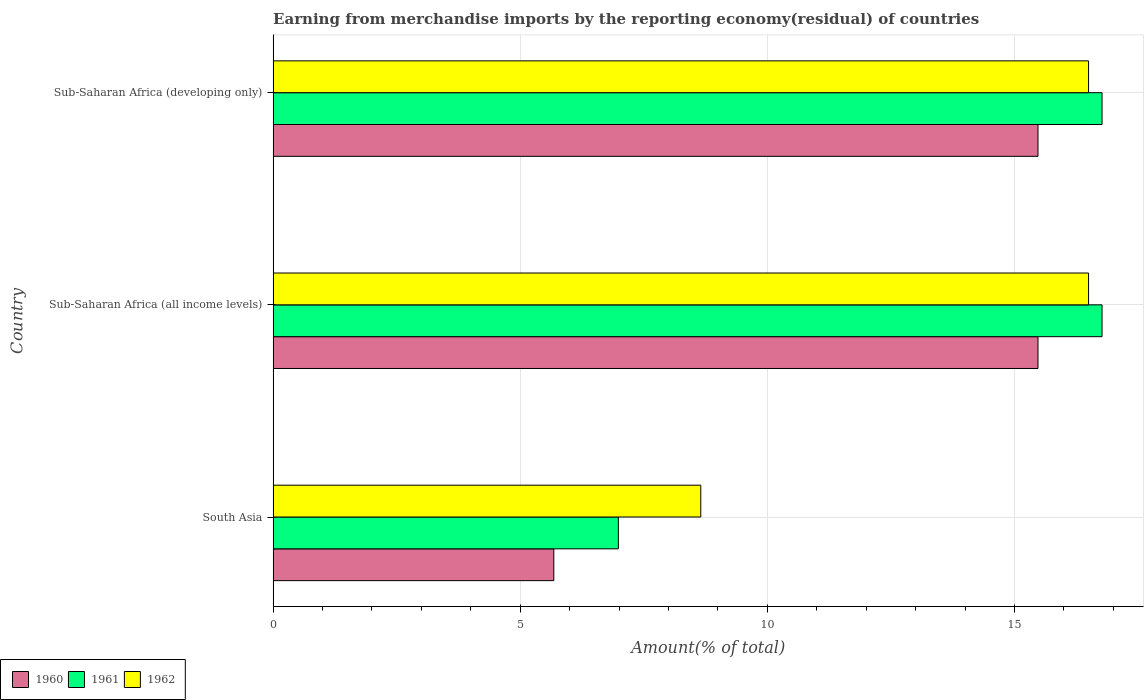Are the number of bars per tick equal to the number of legend labels?
Your answer should be very brief. Yes. Are the number of bars on each tick of the Y-axis equal?
Offer a terse response. Yes. What is the percentage of amount earned from merchandise imports in 1961 in Sub-Saharan Africa (all income levels)?
Your answer should be very brief. 16.77. Across all countries, what is the maximum percentage of amount earned from merchandise imports in 1960?
Your response must be concise. 15.47. Across all countries, what is the minimum percentage of amount earned from merchandise imports in 1961?
Ensure brevity in your answer.  6.98. In which country was the percentage of amount earned from merchandise imports in 1960 maximum?
Provide a short and direct response. Sub-Saharan Africa (all income levels). What is the total percentage of amount earned from merchandise imports in 1960 in the graph?
Your response must be concise. 36.63. What is the difference between the percentage of amount earned from merchandise imports in 1961 in South Asia and that in Sub-Saharan Africa (all income levels)?
Provide a succinct answer. -9.79. What is the difference between the percentage of amount earned from merchandise imports in 1961 in Sub-Saharan Africa (all income levels) and the percentage of amount earned from merchandise imports in 1960 in South Asia?
Your answer should be very brief. 11.09. What is the average percentage of amount earned from merchandise imports in 1962 per country?
Offer a terse response. 13.88. What is the difference between the percentage of amount earned from merchandise imports in 1960 and percentage of amount earned from merchandise imports in 1961 in Sub-Saharan Africa (developing only)?
Ensure brevity in your answer.  -1.3. In how many countries, is the percentage of amount earned from merchandise imports in 1962 greater than 3 %?
Ensure brevity in your answer.  3. What is the ratio of the percentage of amount earned from merchandise imports in 1961 in South Asia to that in Sub-Saharan Africa (developing only)?
Your response must be concise. 0.42. Is the percentage of amount earned from merchandise imports in 1962 in South Asia less than that in Sub-Saharan Africa (all income levels)?
Keep it short and to the point. Yes. What is the difference between the highest and the second highest percentage of amount earned from merchandise imports in 1962?
Give a very brief answer. 0. What is the difference between the highest and the lowest percentage of amount earned from merchandise imports in 1960?
Your response must be concise. 9.8. What does the 3rd bar from the top in Sub-Saharan Africa (all income levels) represents?
Your answer should be compact. 1960. Are all the bars in the graph horizontal?
Keep it short and to the point. Yes. How many countries are there in the graph?
Make the answer very short. 3. What is the difference between two consecutive major ticks on the X-axis?
Your answer should be very brief. 5. Are the values on the major ticks of X-axis written in scientific E-notation?
Keep it short and to the point. No. Where does the legend appear in the graph?
Your answer should be very brief. Bottom left. How are the legend labels stacked?
Provide a short and direct response. Horizontal. What is the title of the graph?
Your answer should be compact. Earning from merchandise imports by the reporting economy(residual) of countries. Does "1990" appear as one of the legend labels in the graph?
Your response must be concise. No. What is the label or title of the X-axis?
Provide a short and direct response. Amount(% of total). What is the Amount(% of total) in 1960 in South Asia?
Your answer should be very brief. 5.68. What is the Amount(% of total) of 1961 in South Asia?
Provide a succinct answer. 6.98. What is the Amount(% of total) in 1962 in South Asia?
Your answer should be compact. 8.65. What is the Amount(% of total) of 1960 in Sub-Saharan Africa (all income levels)?
Ensure brevity in your answer.  15.47. What is the Amount(% of total) in 1961 in Sub-Saharan Africa (all income levels)?
Provide a succinct answer. 16.77. What is the Amount(% of total) in 1962 in Sub-Saharan Africa (all income levels)?
Offer a terse response. 16.5. What is the Amount(% of total) of 1960 in Sub-Saharan Africa (developing only)?
Keep it short and to the point. 15.47. What is the Amount(% of total) in 1961 in Sub-Saharan Africa (developing only)?
Give a very brief answer. 16.77. What is the Amount(% of total) in 1962 in Sub-Saharan Africa (developing only)?
Give a very brief answer. 16.5. Across all countries, what is the maximum Amount(% of total) in 1960?
Make the answer very short. 15.47. Across all countries, what is the maximum Amount(% of total) in 1961?
Your answer should be compact. 16.77. Across all countries, what is the maximum Amount(% of total) in 1962?
Give a very brief answer. 16.5. Across all countries, what is the minimum Amount(% of total) in 1960?
Provide a short and direct response. 5.68. Across all countries, what is the minimum Amount(% of total) of 1961?
Provide a succinct answer. 6.98. Across all countries, what is the minimum Amount(% of total) of 1962?
Keep it short and to the point. 8.65. What is the total Amount(% of total) in 1960 in the graph?
Give a very brief answer. 36.63. What is the total Amount(% of total) in 1961 in the graph?
Offer a terse response. 40.52. What is the total Amount(% of total) of 1962 in the graph?
Make the answer very short. 41.65. What is the difference between the Amount(% of total) in 1960 in South Asia and that in Sub-Saharan Africa (all income levels)?
Your answer should be compact. -9.8. What is the difference between the Amount(% of total) in 1961 in South Asia and that in Sub-Saharan Africa (all income levels)?
Offer a very short reply. -9.79. What is the difference between the Amount(% of total) in 1962 in South Asia and that in Sub-Saharan Africa (all income levels)?
Your response must be concise. -7.84. What is the difference between the Amount(% of total) in 1960 in South Asia and that in Sub-Saharan Africa (developing only)?
Give a very brief answer. -9.8. What is the difference between the Amount(% of total) of 1961 in South Asia and that in Sub-Saharan Africa (developing only)?
Offer a very short reply. -9.79. What is the difference between the Amount(% of total) of 1962 in South Asia and that in Sub-Saharan Africa (developing only)?
Your response must be concise. -7.84. What is the difference between the Amount(% of total) in 1962 in Sub-Saharan Africa (all income levels) and that in Sub-Saharan Africa (developing only)?
Provide a succinct answer. 0. What is the difference between the Amount(% of total) in 1960 in South Asia and the Amount(% of total) in 1961 in Sub-Saharan Africa (all income levels)?
Ensure brevity in your answer.  -11.09. What is the difference between the Amount(% of total) of 1960 in South Asia and the Amount(% of total) of 1962 in Sub-Saharan Africa (all income levels)?
Your response must be concise. -10.82. What is the difference between the Amount(% of total) in 1961 in South Asia and the Amount(% of total) in 1962 in Sub-Saharan Africa (all income levels)?
Your answer should be compact. -9.51. What is the difference between the Amount(% of total) in 1960 in South Asia and the Amount(% of total) in 1961 in Sub-Saharan Africa (developing only)?
Your response must be concise. -11.09. What is the difference between the Amount(% of total) of 1960 in South Asia and the Amount(% of total) of 1962 in Sub-Saharan Africa (developing only)?
Give a very brief answer. -10.82. What is the difference between the Amount(% of total) in 1961 in South Asia and the Amount(% of total) in 1962 in Sub-Saharan Africa (developing only)?
Your answer should be very brief. -9.51. What is the difference between the Amount(% of total) in 1960 in Sub-Saharan Africa (all income levels) and the Amount(% of total) in 1961 in Sub-Saharan Africa (developing only)?
Offer a very short reply. -1.3. What is the difference between the Amount(% of total) of 1960 in Sub-Saharan Africa (all income levels) and the Amount(% of total) of 1962 in Sub-Saharan Africa (developing only)?
Make the answer very short. -1.02. What is the difference between the Amount(% of total) in 1961 in Sub-Saharan Africa (all income levels) and the Amount(% of total) in 1962 in Sub-Saharan Africa (developing only)?
Ensure brevity in your answer.  0.27. What is the average Amount(% of total) of 1960 per country?
Provide a short and direct response. 12.21. What is the average Amount(% of total) of 1961 per country?
Your response must be concise. 13.51. What is the average Amount(% of total) in 1962 per country?
Keep it short and to the point. 13.88. What is the difference between the Amount(% of total) in 1960 and Amount(% of total) in 1961 in South Asia?
Ensure brevity in your answer.  -1.31. What is the difference between the Amount(% of total) of 1960 and Amount(% of total) of 1962 in South Asia?
Offer a terse response. -2.97. What is the difference between the Amount(% of total) of 1961 and Amount(% of total) of 1962 in South Asia?
Your answer should be compact. -1.67. What is the difference between the Amount(% of total) in 1960 and Amount(% of total) in 1961 in Sub-Saharan Africa (all income levels)?
Provide a succinct answer. -1.3. What is the difference between the Amount(% of total) of 1960 and Amount(% of total) of 1962 in Sub-Saharan Africa (all income levels)?
Provide a short and direct response. -1.02. What is the difference between the Amount(% of total) in 1961 and Amount(% of total) in 1962 in Sub-Saharan Africa (all income levels)?
Your answer should be very brief. 0.27. What is the difference between the Amount(% of total) in 1960 and Amount(% of total) in 1961 in Sub-Saharan Africa (developing only)?
Ensure brevity in your answer.  -1.3. What is the difference between the Amount(% of total) in 1960 and Amount(% of total) in 1962 in Sub-Saharan Africa (developing only)?
Keep it short and to the point. -1.02. What is the difference between the Amount(% of total) of 1961 and Amount(% of total) of 1962 in Sub-Saharan Africa (developing only)?
Your response must be concise. 0.27. What is the ratio of the Amount(% of total) in 1960 in South Asia to that in Sub-Saharan Africa (all income levels)?
Give a very brief answer. 0.37. What is the ratio of the Amount(% of total) of 1961 in South Asia to that in Sub-Saharan Africa (all income levels)?
Your answer should be very brief. 0.42. What is the ratio of the Amount(% of total) of 1962 in South Asia to that in Sub-Saharan Africa (all income levels)?
Your answer should be compact. 0.52. What is the ratio of the Amount(% of total) of 1960 in South Asia to that in Sub-Saharan Africa (developing only)?
Your answer should be compact. 0.37. What is the ratio of the Amount(% of total) of 1961 in South Asia to that in Sub-Saharan Africa (developing only)?
Keep it short and to the point. 0.42. What is the ratio of the Amount(% of total) in 1962 in South Asia to that in Sub-Saharan Africa (developing only)?
Your answer should be very brief. 0.52. What is the ratio of the Amount(% of total) in 1960 in Sub-Saharan Africa (all income levels) to that in Sub-Saharan Africa (developing only)?
Make the answer very short. 1. What is the ratio of the Amount(% of total) of 1961 in Sub-Saharan Africa (all income levels) to that in Sub-Saharan Africa (developing only)?
Your answer should be compact. 1. What is the difference between the highest and the second highest Amount(% of total) in 1961?
Make the answer very short. 0. What is the difference between the highest and the lowest Amount(% of total) of 1960?
Ensure brevity in your answer.  9.8. What is the difference between the highest and the lowest Amount(% of total) in 1961?
Offer a very short reply. 9.79. What is the difference between the highest and the lowest Amount(% of total) in 1962?
Your response must be concise. 7.84. 